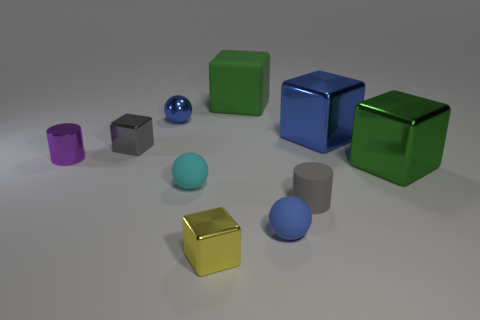The other tiny thing that is the same shape as the gray rubber thing is what color?
Give a very brief answer. Purple. The green metal block has what size?
Provide a short and direct response. Large. There is a big shiny object that is the same color as the large rubber thing; what shape is it?
Your answer should be compact. Cube. Are there more green shiny objects than small shiny cubes?
Your answer should be compact. No. There is a small cylinder that is right of the large rubber thing that is behind the tiny gray object that is right of the tiny cyan sphere; what is its color?
Provide a succinct answer. Gray. There is a gray thing that is behind the purple thing; does it have the same shape as the yellow shiny object?
Provide a succinct answer. Yes. There is a cylinder that is the same size as the purple shiny thing; what is its color?
Provide a succinct answer. Gray. What number of large green matte cubes are there?
Your answer should be very brief. 1. Are the blue thing that is to the right of the blue matte sphere and the cyan sphere made of the same material?
Your answer should be very brief. No. What is the blue object that is both behind the big green metallic thing and to the left of the gray cylinder made of?
Offer a terse response. Metal. 